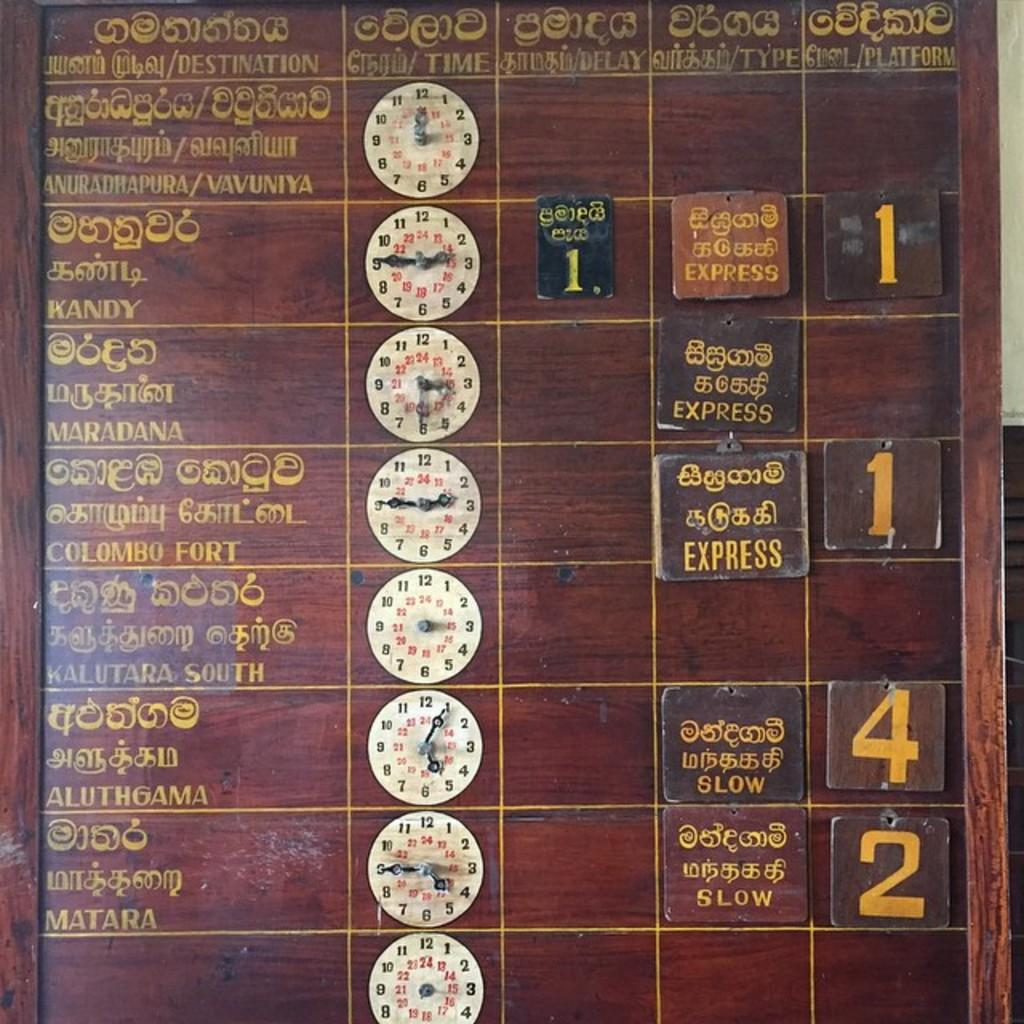<image>
Offer a succinct explanation of the picture presented. An arrivals and departures board contains signs for SLOW and EXPRESS. 